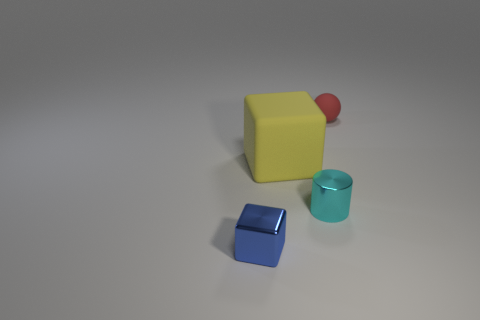Add 1 big purple rubber things. How many objects exist? 5 Subtract all balls. How many objects are left? 3 Add 4 tiny red spheres. How many tiny red spheres are left? 5 Add 2 green rubber blocks. How many green rubber blocks exist? 2 Subtract all yellow blocks. How many blocks are left? 1 Subtract 0 blue balls. How many objects are left? 4 Subtract 1 cubes. How many cubes are left? 1 Subtract all purple balls. Subtract all red cylinders. How many balls are left? 1 Subtract all cyan spheres. How many blue cubes are left? 1 Subtract all large blue matte cylinders. Subtract all small cubes. How many objects are left? 3 